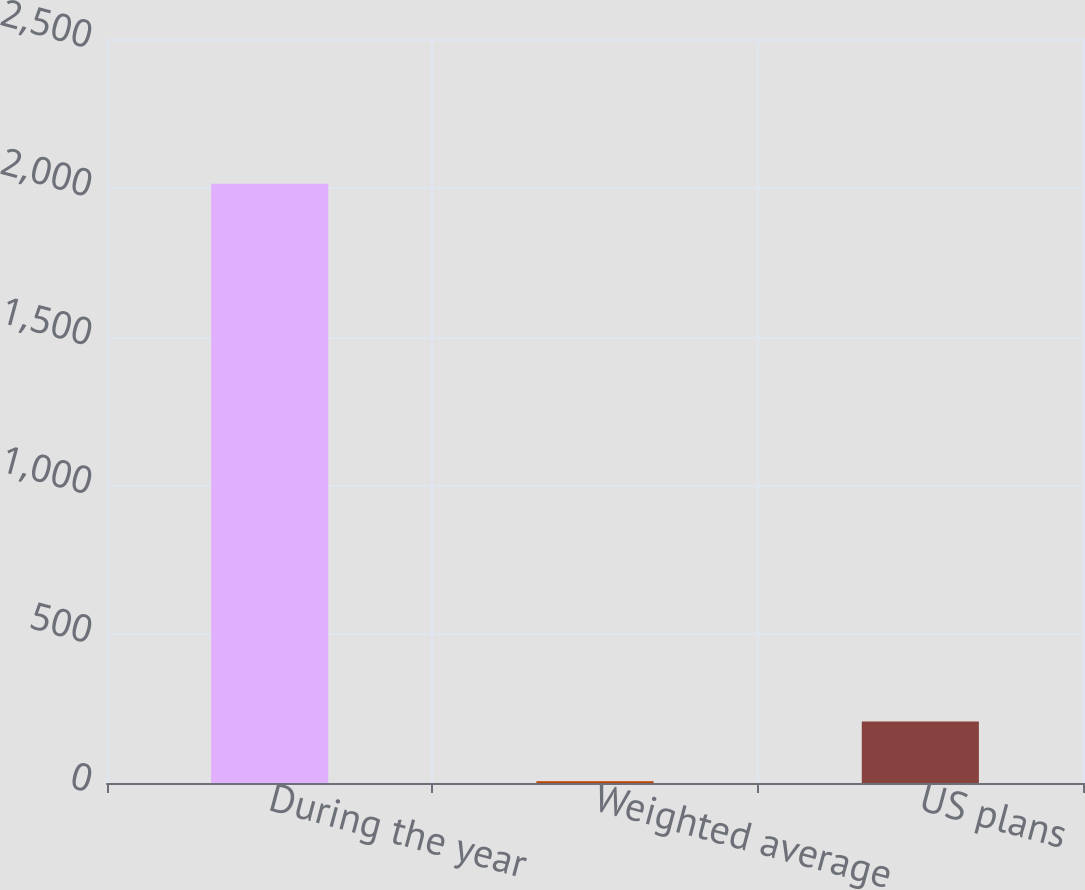Convert chart. <chart><loc_0><loc_0><loc_500><loc_500><bar_chart><fcel>During the year<fcel>Weighted average<fcel>US plans<nl><fcel>2014<fcel>5.6<fcel>206.44<nl></chart> 